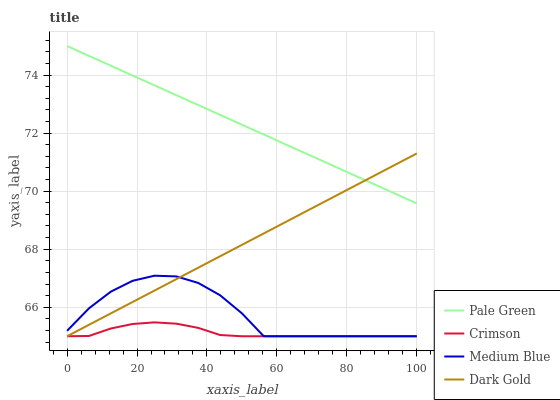Does Crimson have the minimum area under the curve?
Answer yes or no. Yes. Does Pale Green have the maximum area under the curve?
Answer yes or no. Yes. Does Medium Blue have the minimum area under the curve?
Answer yes or no. No. Does Medium Blue have the maximum area under the curve?
Answer yes or no. No. Is Dark Gold the smoothest?
Answer yes or no. Yes. Is Medium Blue the roughest?
Answer yes or no. Yes. Is Pale Green the smoothest?
Answer yes or no. No. Is Pale Green the roughest?
Answer yes or no. No. Does Crimson have the lowest value?
Answer yes or no. Yes. Does Pale Green have the lowest value?
Answer yes or no. No. Does Pale Green have the highest value?
Answer yes or no. Yes. Does Medium Blue have the highest value?
Answer yes or no. No. Is Crimson less than Pale Green?
Answer yes or no. Yes. Is Pale Green greater than Crimson?
Answer yes or no. Yes. Does Crimson intersect Medium Blue?
Answer yes or no. Yes. Is Crimson less than Medium Blue?
Answer yes or no. No. Is Crimson greater than Medium Blue?
Answer yes or no. No. Does Crimson intersect Pale Green?
Answer yes or no. No. 